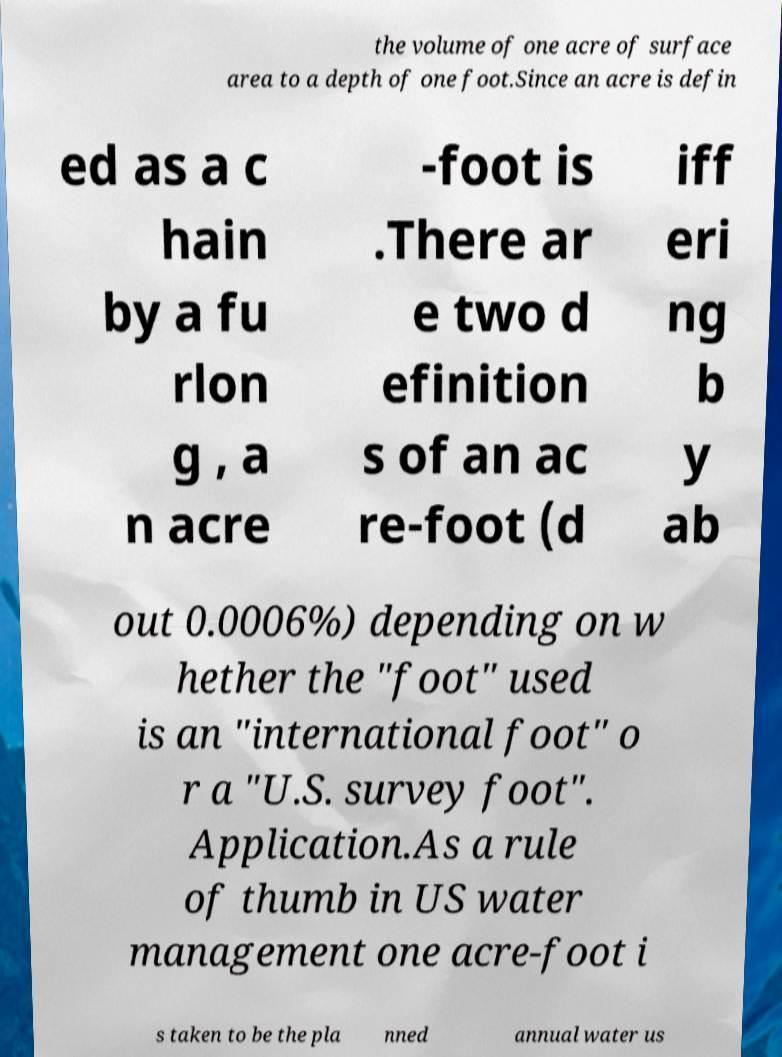Could you assist in decoding the text presented in this image and type it out clearly? the volume of one acre of surface area to a depth of one foot.Since an acre is defin ed as a c hain by a fu rlon g , a n acre -foot is .There ar e two d efinition s of an ac re-foot (d iff eri ng b y ab out 0.0006%) depending on w hether the "foot" used is an "international foot" o r a "U.S. survey foot". Application.As a rule of thumb in US water management one acre-foot i s taken to be the pla nned annual water us 